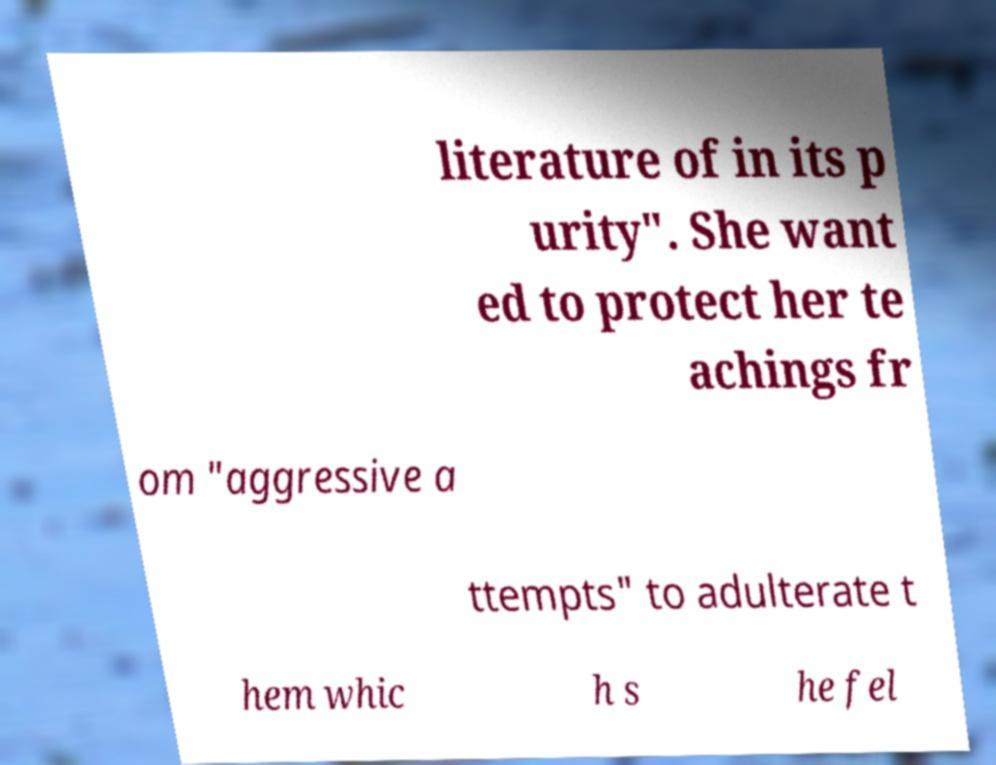I need the written content from this picture converted into text. Can you do that? literature of in its p urity". She want ed to protect her te achings fr om "aggressive a ttempts" to adulterate t hem whic h s he fel 